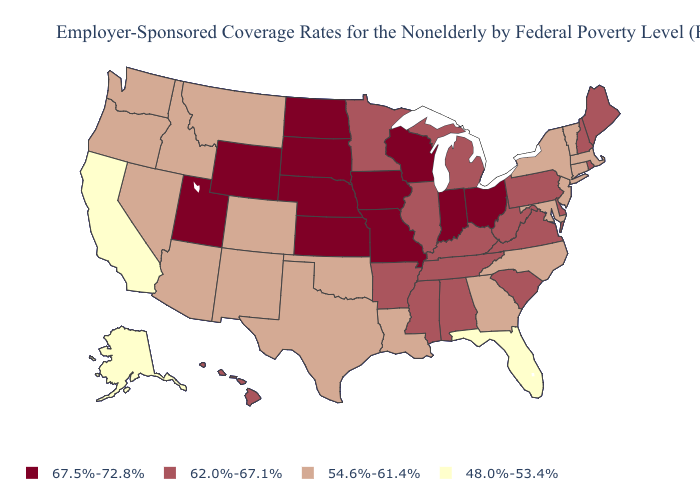Does Vermont have the highest value in the USA?
Give a very brief answer. No. Is the legend a continuous bar?
Quick response, please. No. What is the value of California?
Keep it brief. 48.0%-53.4%. Name the states that have a value in the range 62.0%-67.1%?
Give a very brief answer. Alabama, Arkansas, Delaware, Hawaii, Illinois, Kentucky, Maine, Michigan, Minnesota, Mississippi, New Hampshire, Pennsylvania, Rhode Island, South Carolina, Tennessee, Virginia, West Virginia. Among the states that border Ohio , which have the lowest value?
Be succinct. Kentucky, Michigan, Pennsylvania, West Virginia. Which states hav the highest value in the Northeast?
Answer briefly. Maine, New Hampshire, Pennsylvania, Rhode Island. What is the value of Arkansas?
Short answer required. 62.0%-67.1%. What is the highest value in the USA?
Be succinct. 67.5%-72.8%. Which states have the lowest value in the USA?
Give a very brief answer. Alaska, California, Florida. Among the states that border Ohio , does Indiana have the lowest value?
Keep it brief. No. Name the states that have a value in the range 54.6%-61.4%?
Keep it brief. Arizona, Colorado, Connecticut, Georgia, Idaho, Louisiana, Maryland, Massachusetts, Montana, Nevada, New Jersey, New Mexico, New York, North Carolina, Oklahoma, Oregon, Texas, Vermont, Washington. Does New Jersey have a lower value than Utah?
Answer briefly. Yes. Does California have the lowest value in the USA?
Answer briefly. Yes. Does Pennsylvania have the highest value in the USA?
Keep it brief. No. 